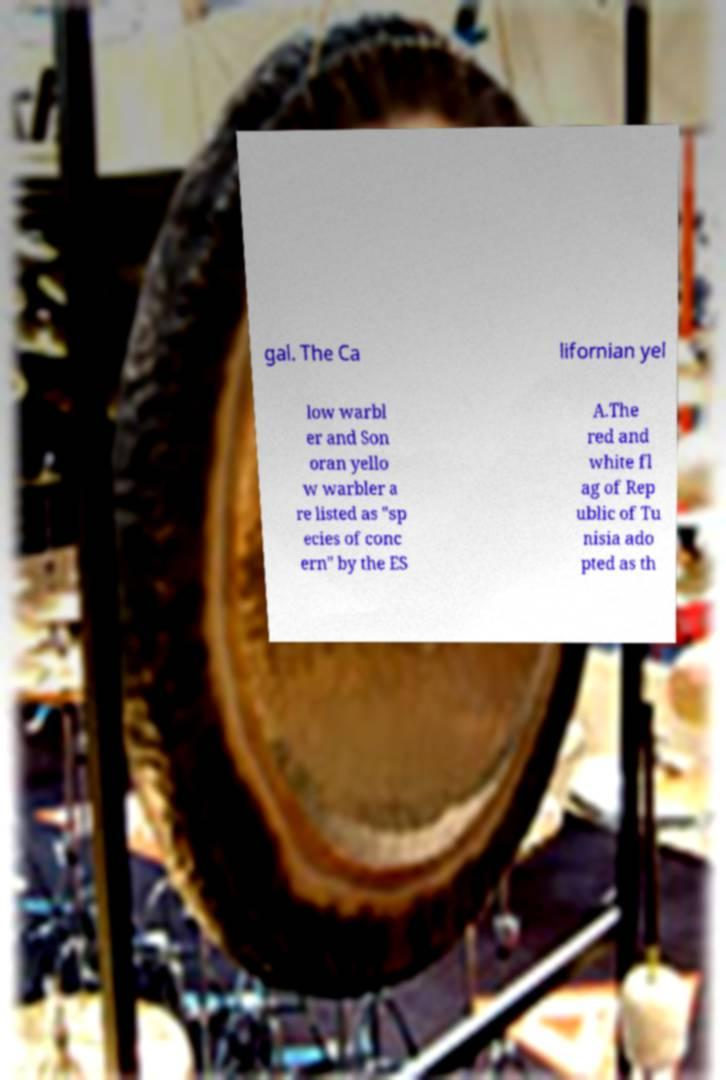Could you extract and type out the text from this image? gal. The Ca lifornian yel low warbl er and Son oran yello w warbler a re listed as "sp ecies of conc ern" by the ES A.The red and white fl ag of Rep ublic of Tu nisia ado pted as th 